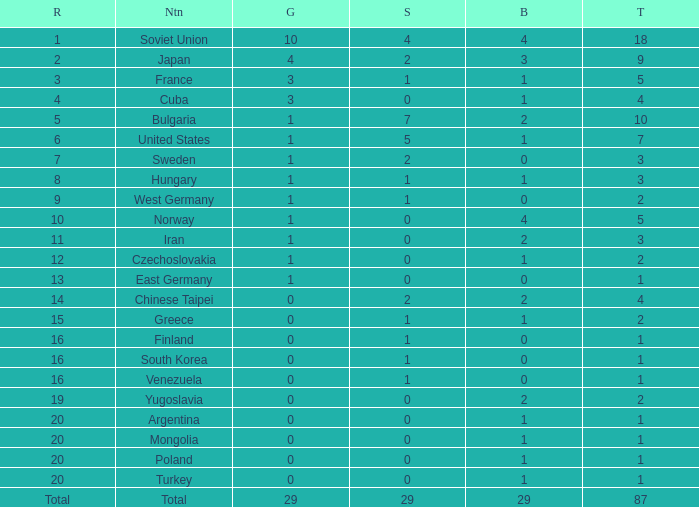Which rank has 1 silver medal and more than 1 gold medal? 3.0. Would you be able to parse every entry in this table? {'header': ['R', 'Ntn', 'G', 'S', 'B', 'T'], 'rows': [['1', 'Soviet Union', '10', '4', '4', '18'], ['2', 'Japan', '4', '2', '3', '9'], ['3', 'France', '3', '1', '1', '5'], ['4', 'Cuba', '3', '0', '1', '4'], ['5', 'Bulgaria', '1', '7', '2', '10'], ['6', 'United States', '1', '5', '1', '7'], ['7', 'Sweden', '1', '2', '0', '3'], ['8', 'Hungary', '1', '1', '1', '3'], ['9', 'West Germany', '1', '1', '0', '2'], ['10', 'Norway', '1', '0', '4', '5'], ['11', 'Iran', '1', '0', '2', '3'], ['12', 'Czechoslovakia', '1', '0', '1', '2'], ['13', 'East Germany', '1', '0', '0', '1'], ['14', 'Chinese Taipei', '0', '2', '2', '4'], ['15', 'Greece', '0', '1', '1', '2'], ['16', 'Finland', '0', '1', '0', '1'], ['16', 'South Korea', '0', '1', '0', '1'], ['16', 'Venezuela', '0', '1', '0', '1'], ['19', 'Yugoslavia', '0', '0', '2', '2'], ['20', 'Argentina', '0', '0', '1', '1'], ['20', 'Mongolia', '0', '0', '1', '1'], ['20', 'Poland', '0', '0', '1', '1'], ['20', 'Turkey', '0', '0', '1', '1'], ['Total', 'Total', '29', '29', '29', '87']]} 